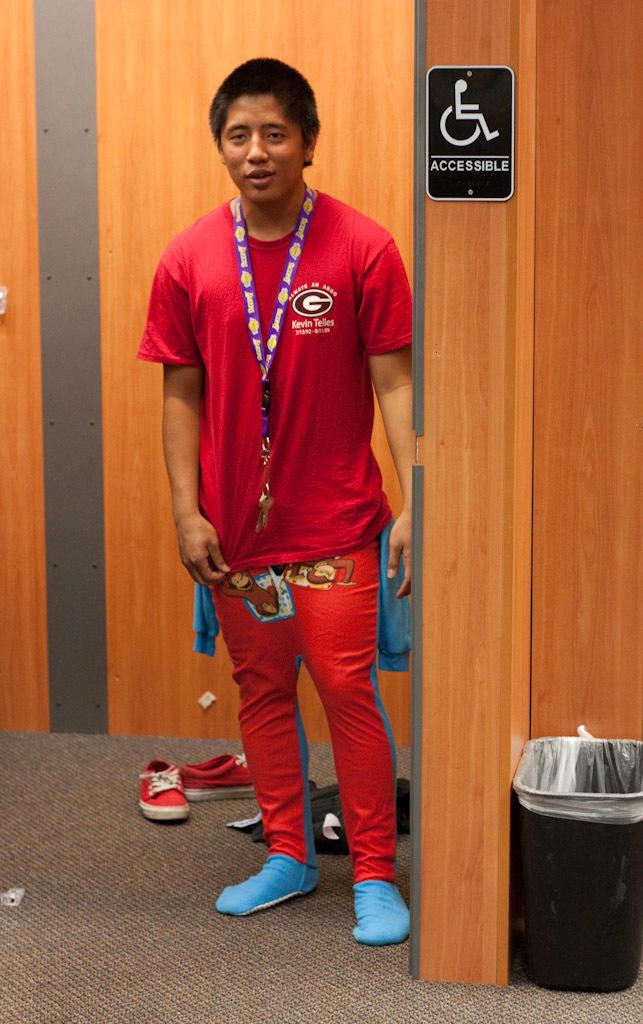What type of sign is on the door?
Keep it short and to the point. Accessible. Whose name is on the man's t-shirt?
Give a very brief answer. Kevin telles. 